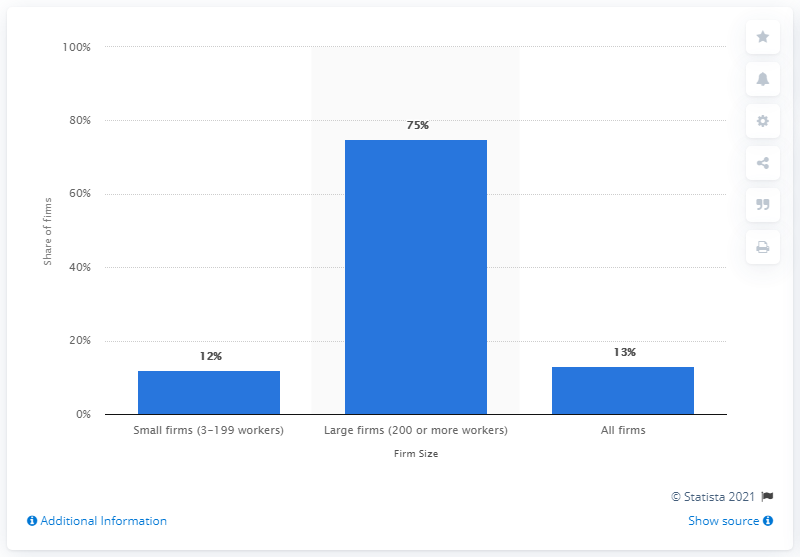Identify some key points in this picture. In 2016, it was reported that 12% of small firms offered flexible spending accounts. 